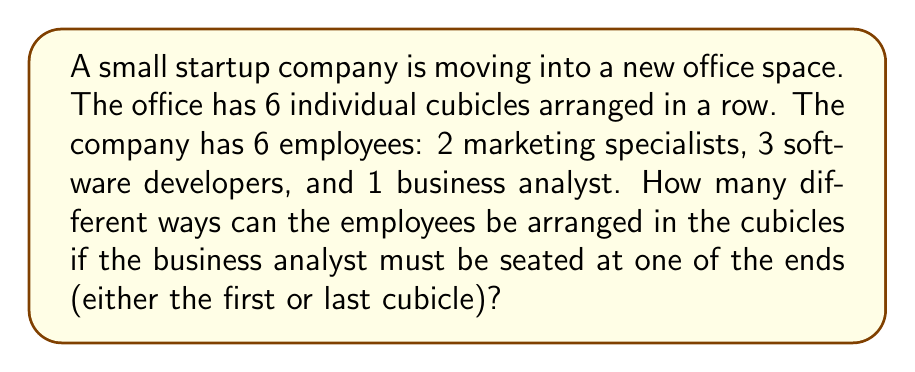Can you solve this math problem? Let's approach this step-by-step:

1) First, we need to consider the business analyst's position. They can be placed in either the first or last cubicle. This gives us 2 choices for their position.

2) Once the business analyst is placed, we need to arrange the remaining 5 employees in the remaining 5 cubicles.

3) This is a permutation problem. We have 5 employees (2 marketing specialists and 3 software developers) to arrange in 5 positions.

4) However, this is not a straightforward permutation because we have repeated elements (2 marketing specialists and 3 software developers). We need to use the formula for permutations with repetition:

   $$\frac{n!}{n_1!n_2!...n_k!}$$

   Where $n$ is the total number of items, and $n_1, n_2, ..., n_k$ are the numbers of each type of item.

5) In our case:
   $n = 5$ (total positions to fill)
   $n_1 = 2$ (marketing specialists)
   $n_2 = 3$ (software developers)

6) Plugging into the formula:

   $$\frac{5!}{2!3!} = \frac{5 \times 4 \times 3 \times 2 \times 1}{(2 \times 1)(3 \times 2 \times 1)} = \frac{120}{12} = 10$$

7) This gives us 10 ways to arrange the 5 employees in the 5 remaining cubicles.

8) Remember, we have 2 choices for the business analyst's position. For each of these 2 choices, we can have any of the 10 arrangements of the other employees.

9) Therefore, the total number of arrangements is:

   $$2 \times 10 = 20$$

Thus, there are 20 different ways to arrange the employees in the cubicles.
Answer: 20 ways 